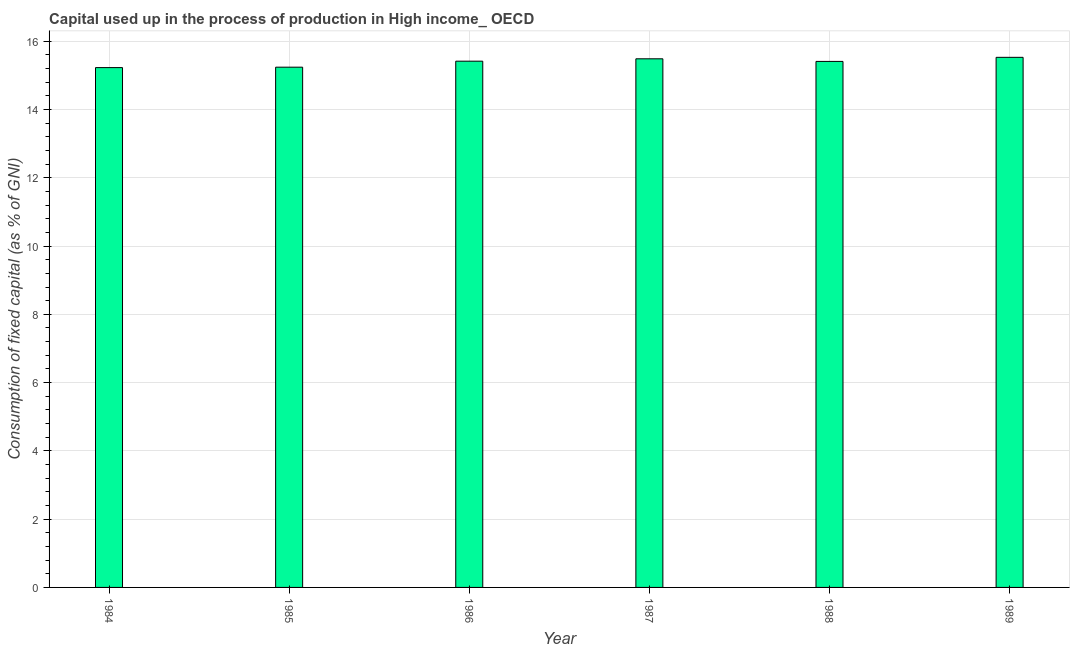Does the graph contain any zero values?
Make the answer very short. No. Does the graph contain grids?
Make the answer very short. Yes. What is the title of the graph?
Offer a terse response. Capital used up in the process of production in High income_ OECD. What is the label or title of the Y-axis?
Offer a terse response. Consumption of fixed capital (as % of GNI). What is the consumption of fixed capital in 1984?
Provide a succinct answer. 15.23. Across all years, what is the maximum consumption of fixed capital?
Make the answer very short. 15.53. Across all years, what is the minimum consumption of fixed capital?
Provide a succinct answer. 15.23. In which year was the consumption of fixed capital minimum?
Provide a succinct answer. 1984. What is the sum of the consumption of fixed capital?
Provide a short and direct response. 92.3. What is the difference between the consumption of fixed capital in 1984 and 1988?
Your response must be concise. -0.18. What is the average consumption of fixed capital per year?
Ensure brevity in your answer.  15.38. What is the median consumption of fixed capital?
Ensure brevity in your answer.  15.41. What is the ratio of the consumption of fixed capital in 1984 to that in 1985?
Make the answer very short. 1. What is the difference between the highest and the second highest consumption of fixed capital?
Your answer should be compact. 0.04. What is the difference between the highest and the lowest consumption of fixed capital?
Provide a short and direct response. 0.3. In how many years, is the consumption of fixed capital greater than the average consumption of fixed capital taken over all years?
Offer a very short reply. 4. Are all the bars in the graph horizontal?
Offer a very short reply. No. Are the values on the major ticks of Y-axis written in scientific E-notation?
Your answer should be compact. No. What is the Consumption of fixed capital (as % of GNI) in 1984?
Provide a short and direct response. 15.23. What is the Consumption of fixed capital (as % of GNI) in 1985?
Your answer should be compact. 15.24. What is the Consumption of fixed capital (as % of GNI) of 1986?
Provide a succinct answer. 15.42. What is the Consumption of fixed capital (as % of GNI) in 1987?
Make the answer very short. 15.48. What is the Consumption of fixed capital (as % of GNI) of 1988?
Provide a succinct answer. 15.41. What is the Consumption of fixed capital (as % of GNI) in 1989?
Offer a very short reply. 15.53. What is the difference between the Consumption of fixed capital (as % of GNI) in 1984 and 1985?
Provide a succinct answer. -0.01. What is the difference between the Consumption of fixed capital (as % of GNI) in 1984 and 1986?
Ensure brevity in your answer.  -0.19. What is the difference between the Consumption of fixed capital (as % of GNI) in 1984 and 1987?
Provide a short and direct response. -0.26. What is the difference between the Consumption of fixed capital (as % of GNI) in 1984 and 1988?
Your answer should be very brief. -0.18. What is the difference between the Consumption of fixed capital (as % of GNI) in 1984 and 1989?
Provide a short and direct response. -0.3. What is the difference between the Consumption of fixed capital (as % of GNI) in 1985 and 1986?
Your answer should be very brief. -0.18. What is the difference between the Consumption of fixed capital (as % of GNI) in 1985 and 1987?
Provide a short and direct response. -0.25. What is the difference between the Consumption of fixed capital (as % of GNI) in 1985 and 1988?
Make the answer very short. -0.17. What is the difference between the Consumption of fixed capital (as % of GNI) in 1985 and 1989?
Offer a terse response. -0.29. What is the difference between the Consumption of fixed capital (as % of GNI) in 1986 and 1987?
Keep it short and to the point. -0.07. What is the difference between the Consumption of fixed capital (as % of GNI) in 1986 and 1988?
Offer a terse response. 0.01. What is the difference between the Consumption of fixed capital (as % of GNI) in 1986 and 1989?
Your answer should be compact. -0.11. What is the difference between the Consumption of fixed capital (as % of GNI) in 1987 and 1988?
Make the answer very short. 0.08. What is the difference between the Consumption of fixed capital (as % of GNI) in 1987 and 1989?
Provide a short and direct response. -0.04. What is the difference between the Consumption of fixed capital (as % of GNI) in 1988 and 1989?
Provide a short and direct response. -0.12. What is the ratio of the Consumption of fixed capital (as % of GNI) in 1984 to that in 1985?
Keep it short and to the point. 1. What is the ratio of the Consumption of fixed capital (as % of GNI) in 1984 to that in 1986?
Offer a terse response. 0.99. What is the ratio of the Consumption of fixed capital (as % of GNI) in 1984 to that in 1987?
Give a very brief answer. 0.98. What is the ratio of the Consumption of fixed capital (as % of GNI) in 1985 to that in 1987?
Your answer should be very brief. 0.98. What is the ratio of the Consumption of fixed capital (as % of GNI) in 1985 to that in 1988?
Provide a succinct answer. 0.99. What is the ratio of the Consumption of fixed capital (as % of GNI) in 1986 to that in 1987?
Your response must be concise. 1. What is the ratio of the Consumption of fixed capital (as % of GNI) in 1986 to that in 1988?
Make the answer very short. 1. What is the ratio of the Consumption of fixed capital (as % of GNI) in 1986 to that in 1989?
Your answer should be very brief. 0.99. What is the ratio of the Consumption of fixed capital (as % of GNI) in 1987 to that in 1989?
Offer a very short reply. 1. What is the ratio of the Consumption of fixed capital (as % of GNI) in 1988 to that in 1989?
Offer a terse response. 0.99. 